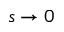Convert formula to latex. <formula><loc_0><loc_0><loc_500><loc_500>s \rightarrow 0</formula> 